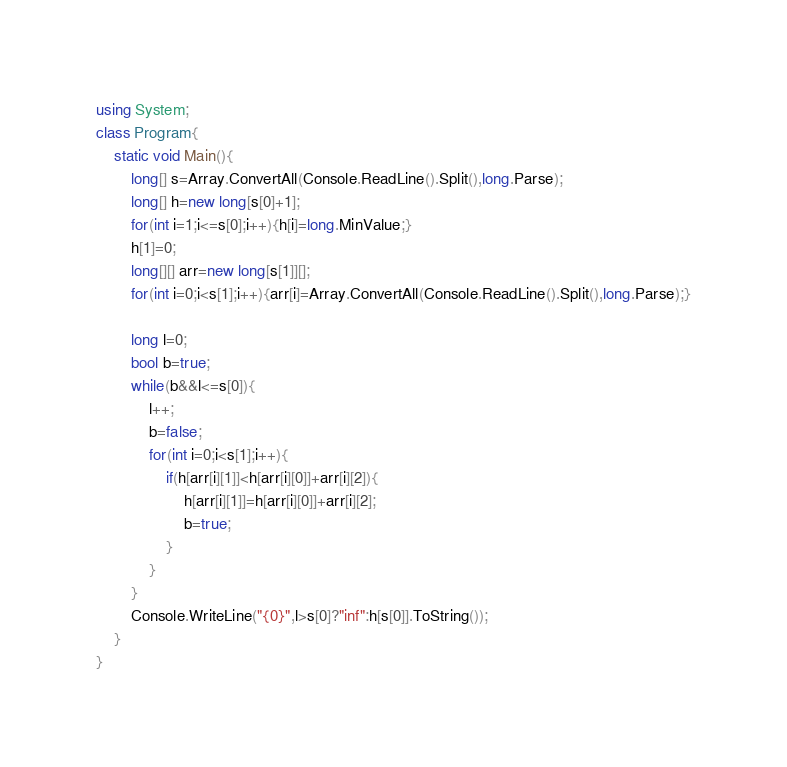Convert code to text. <code><loc_0><loc_0><loc_500><loc_500><_C#_>using System;
class Program{
	static void Main(){
		long[] s=Array.ConvertAll(Console.ReadLine().Split(),long.Parse);
		long[] h=new long[s[0]+1];
		for(int i=1;i<=s[0];i++){h[i]=long.MinValue;}
		h[1]=0;
		long[][] arr=new long[s[1]][];
		for(int i=0;i<s[1];i++){arr[i]=Array.ConvertAll(Console.ReadLine().Split(),long.Parse);}

		long l=0;
		bool b=true;
		while(b&&l<=s[0]){
			l++;
			b=false;
			for(int i=0;i<s[1];i++){
				if(h[arr[i][1]]<h[arr[i][0]]+arr[i][2]){
					h[arr[i][1]]=h[arr[i][0]]+arr[i][2];
					b=true;
				}
			}
		}
		Console.WriteLine("{0}",l>s[0]?"inf":h[s[0]].ToString());
	}
}</code> 